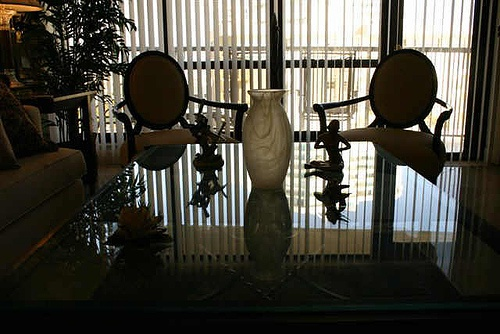Describe the objects in this image and their specific colors. I can see couch in black tones, potted plant in black, gray, darkgray, and white tones, chair in black, ivory, darkgray, and tan tones, chair in black, gray, and ivory tones, and vase in black and gray tones in this image. 